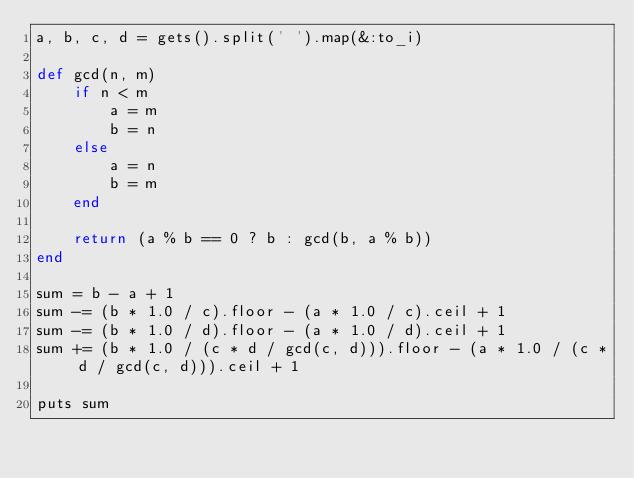Convert code to text. <code><loc_0><loc_0><loc_500><loc_500><_Ruby_>a, b, c, d = gets().split(' ').map(&:to_i)

def gcd(n, m)
	if n < m
		a = m
		b = n
	else
		a = n
		b = m
	end

	return (a % b == 0 ? b : gcd(b, a % b))
end

sum = b - a + 1
sum -= (b * 1.0 / c).floor - (a * 1.0 / c).ceil + 1
sum -= (b * 1.0 / d).floor - (a * 1.0 / d).ceil + 1
sum += (b * 1.0 / (c * d / gcd(c, d))).floor - (a * 1.0 / (c * d / gcd(c, d))).ceil + 1

puts sum
</code> 